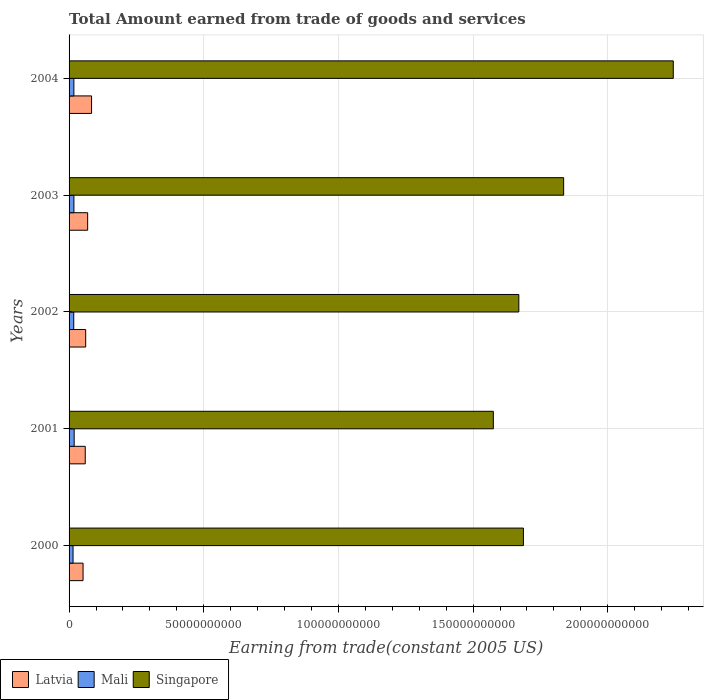Are the number of bars per tick equal to the number of legend labels?
Keep it short and to the point. Yes. Are the number of bars on each tick of the Y-axis equal?
Make the answer very short. Yes. What is the label of the 3rd group of bars from the top?
Your answer should be very brief. 2002. In how many cases, is the number of bars for a given year not equal to the number of legend labels?
Keep it short and to the point. 0. What is the total amount earned by trading goods and services in Mali in 2001?
Ensure brevity in your answer.  1.90e+09. Across all years, what is the maximum total amount earned by trading goods and services in Singapore?
Give a very brief answer. 2.24e+11. Across all years, what is the minimum total amount earned by trading goods and services in Singapore?
Keep it short and to the point. 1.58e+11. In which year was the total amount earned by trading goods and services in Latvia minimum?
Your answer should be very brief. 2000. What is the total total amount earned by trading goods and services in Latvia in the graph?
Provide a succinct answer. 3.26e+1. What is the difference between the total amount earned by trading goods and services in Latvia in 2003 and that in 2004?
Make the answer very short. -1.45e+09. What is the difference between the total amount earned by trading goods and services in Singapore in 2000 and the total amount earned by trading goods and services in Mali in 2003?
Offer a terse response. 1.67e+11. What is the average total amount earned by trading goods and services in Singapore per year?
Offer a terse response. 1.80e+11. In the year 2001, what is the difference between the total amount earned by trading goods and services in Latvia and total amount earned by trading goods and services in Singapore?
Provide a succinct answer. -1.52e+11. In how many years, is the total amount earned by trading goods and services in Mali greater than 220000000000 US$?
Offer a very short reply. 0. What is the ratio of the total amount earned by trading goods and services in Latvia in 2000 to that in 2004?
Your response must be concise. 0.62. What is the difference between the highest and the second highest total amount earned by trading goods and services in Mali?
Keep it short and to the point. 9.78e+07. What is the difference between the highest and the lowest total amount earned by trading goods and services in Latvia?
Provide a short and direct response. 3.16e+09. In how many years, is the total amount earned by trading goods and services in Latvia greater than the average total amount earned by trading goods and services in Latvia taken over all years?
Give a very brief answer. 2. What does the 1st bar from the top in 2004 represents?
Provide a short and direct response. Singapore. What does the 1st bar from the bottom in 2003 represents?
Keep it short and to the point. Latvia. Is it the case that in every year, the sum of the total amount earned by trading goods and services in Mali and total amount earned by trading goods and services in Latvia is greater than the total amount earned by trading goods and services in Singapore?
Make the answer very short. No. Are all the bars in the graph horizontal?
Your answer should be compact. Yes. What is the difference between two consecutive major ticks on the X-axis?
Offer a very short reply. 5.00e+1. Are the values on the major ticks of X-axis written in scientific E-notation?
Your response must be concise. No. Does the graph contain grids?
Your answer should be very brief. Yes. How many legend labels are there?
Offer a terse response. 3. How are the legend labels stacked?
Provide a succinct answer. Horizontal. What is the title of the graph?
Provide a succinct answer. Total Amount earned from trade of goods and services. What is the label or title of the X-axis?
Offer a very short reply. Earning from trade(constant 2005 US). What is the Earning from trade(constant 2005 US) in Latvia in 2000?
Offer a very short reply. 5.19e+09. What is the Earning from trade(constant 2005 US) of Mali in 2000?
Provide a succinct answer. 1.48e+09. What is the Earning from trade(constant 2005 US) of Singapore in 2000?
Provide a succinct answer. 1.69e+11. What is the Earning from trade(constant 2005 US) of Latvia in 2001?
Your answer should be very brief. 6.00e+09. What is the Earning from trade(constant 2005 US) in Mali in 2001?
Provide a succinct answer. 1.90e+09. What is the Earning from trade(constant 2005 US) in Singapore in 2001?
Keep it short and to the point. 1.58e+11. What is the Earning from trade(constant 2005 US) of Latvia in 2002?
Give a very brief answer. 6.17e+09. What is the Earning from trade(constant 2005 US) of Mali in 2002?
Your answer should be compact. 1.74e+09. What is the Earning from trade(constant 2005 US) in Singapore in 2002?
Make the answer very short. 1.67e+11. What is the Earning from trade(constant 2005 US) in Latvia in 2003?
Offer a terse response. 6.90e+09. What is the Earning from trade(constant 2005 US) of Mali in 2003?
Keep it short and to the point. 1.80e+09. What is the Earning from trade(constant 2005 US) of Singapore in 2003?
Ensure brevity in your answer.  1.84e+11. What is the Earning from trade(constant 2005 US) in Latvia in 2004?
Ensure brevity in your answer.  8.35e+09. What is the Earning from trade(constant 2005 US) in Mali in 2004?
Ensure brevity in your answer.  1.78e+09. What is the Earning from trade(constant 2005 US) in Singapore in 2004?
Give a very brief answer. 2.24e+11. Across all years, what is the maximum Earning from trade(constant 2005 US) in Latvia?
Make the answer very short. 8.35e+09. Across all years, what is the maximum Earning from trade(constant 2005 US) of Mali?
Ensure brevity in your answer.  1.90e+09. Across all years, what is the maximum Earning from trade(constant 2005 US) of Singapore?
Your response must be concise. 2.24e+11. Across all years, what is the minimum Earning from trade(constant 2005 US) of Latvia?
Your answer should be compact. 5.19e+09. Across all years, what is the minimum Earning from trade(constant 2005 US) in Mali?
Keep it short and to the point. 1.48e+09. Across all years, what is the minimum Earning from trade(constant 2005 US) of Singapore?
Ensure brevity in your answer.  1.58e+11. What is the total Earning from trade(constant 2005 US) of Latvia in the graph?
Offer a terse response. 3.26e+1. What is the total Earning from trade(constant 2005 US) in Mali in the graph?
Offer a very short reply. 8.69e+09. What is the total Earning from trade(constant 2005 US) of Singapore in the graph?
Provide a short and direct response. 9.01e+11. What is the difference between the Earning from trade(constant 2005 US) in Latvia in 2000 and that in 2001?
Your answer should be compact. -8.12e+08. What is the difference between the Earning from trade(constant 2005 US) of Mali in 2000 and that in 2001?
Offer a terse response. -4.19e+08. What is the difference between the Earning from trade(constant 2005 US) of Singapore in 2000 and that in 2001?
Provide a short and direct response. 1.12e+1. What is the difference between the Earning from trade(constant 2005 US) of Latvia in 2000 and that in 2002?
Ensure brevity in your answer.  -9.75e+08. What is the difference between the Earning from trade(constant 2005 US) of Mali in 2000 and that in 2002?
Keep it short and to the point. -2.61e+08. What is the difference between the Earning from trade(constant 2005 US) of Singapore in 2000 and that in 2002?
Give a very brief answer. 1.71e+09. What is the difference between the Earning from trade(constant 2005 US) in Latvia in 2000 and that in 2003?
Your answer should be compact. -1.71e+09. What is the difference between the Earning from trade(constant 2005 US) of Mali in 2000 and that in 2003?
Give a very brief answer. -3.21e+08. What is the difference between the Earning from trade(constant 2005 US) of Singapore in 2000 and that in 2003?
Your response must be concise. -1.49e+1. What is the difference between the Earning from trade(constant 2005 US) in Latvia in 2000 and that in 2004?
Your response must be concise. -3.16e+09. What is the difference between the Earning from trade(constant 2005 US) of Mali in 2000 and that in 2004?
Offer a terse response. -3.04e+08. What is the difference between the Earning from trade(constant 2005 US) in Singapore in 2000 and that in 2004?
Your response must be concise. -5.56e+1. What is the difference between the Earning from trade(constant 2005 US) of Latvia in 2001 and that in 2002?
Keep it short and to the point. -1.63e+08. What is the difference between the Earning from trade(constant 2005 US) of Mali in 2001 and that in 2002?
Ensure brevity in your answer.  1.57e+08. What is the difference between the Earning from trade(constant 2005 US) of Singapore in 2001 and that in 2002?
Make the answer very short. -9.46e+09. What is the difference between the Earning from trade(constant 2005 US) in Latvia in 2001 and that in 2003?
Give a very brief answer. -8.95e+08. What is the difference between the Earning from trade(constant 2005 US) of Mali in 2001 and that in 2003?
Make the answer very short. 9.78e+07. What is the difference between the Earning from trade(constant 2005 US) in Singapore in 2001 and that in 2003?
Give a very brief answer. -2.61e+1. What is the difference between the Earning from trade(constant 2005 US) of Latvia in 2001 and that in 2004?
Your response must be concise. -2.35e+09. What is the difference between the Earning from trade(constant 2005 US) in Mali in 2001 and that in 2004?
Ensure brevity in your answer.  1.15e+08. What is the difference between the Earning from trade(constant 2005 US) in Singapore in 2001 and that in 2004?
Offer a terse response. -6.68e+1. What is the difference between the Earning from trade(constant 2005 US) in Latvia in 2002 and that in 2003?
Ensure brevity in your answer.  -7.32e+08. What is the difference between the Earning from trade(constant 2005 US) in Mali in 2002 and that in 2003?
Provide a short and direct response. -5.94e+07. What is the difference between the Earning from trade(constant 2005 US) of Singapore in 2002 and that in 2003?
Offer a terse response. -1.66e+1. What is the difference between the Earning from trade(constant 2005 US) in Latvia in 2002 and that in 2004?
Provide a succinct answer. -2.18e+09. What is the difference between the Earning from trade(constant 2005 US) in Mali in 2002 and that in 2004?
Give a very brief answer. -4.25e+07. What is the difference between the Earning from trade(constant 2005 US) of Singapore in 2002 and that in 2004?
Provide a succinct answer. -5.73e+1. What is the difference between the Earning from trade(constant 2005 US) of Latvia in 2003 and that in 2004?
Provide a succinct answer. -1.45e+09. What is the difference between the Earning from trade(constant 2005 US) of Mali in 2003 and that in 2004?
Provide a succinct answer. 1.68e+07. What is the difference between the Earning from trade(constant 2005 US) of Singapore in 2003 and that in 2004?
Your answer should be compact. -4.07e+1. What is the difference between the Earning from trade(constant 2005 US) of Latvia in 2000 and the Earning from trade(constant 2005 US) of Mali in 2001?
Your answer should be very brief. 3.30e+09. What is the difference between the Earning from trade(constant 2005 US) of Latvia in 2000 and the Earning from trade(constant 2005 US) of Singapore in 2001?
Make the answer very short. -1.52e+11. What is the difference between the Earning from trade(constant 2005 US) in Mali in 2000 and the Earning from trade(constant 2005 US) in Singapore in 2001?
Your answer should be compact. -1.56e+11. What is the difference between the Earning from trade(constant 2005 US) of Latvia in 2000 and the Earning from trade(constant 2005 US) of Mali in 2002?
Offer a very short reply. 3.45e+09. What is the difference between the Earning from trade(constant 2005 US) of Latvia in 2000 and the Earning from trade(constant 2005 US) of Singapore in 2002?
Your answer should be very brief. -1.62e+11. What is the difference between the Earning from trade(constant 2005 US) in Mali in 2000 and the Earning from trade(constant 2005 US) in Singapore in 2002?
Make the answer very short. -1.65e+11. What is the difference between the Earning from trade(constant 2005 US) of Latvia in 2000 and the Earning from trade(constant 2005 US) of Mali in 2003?
Your answer should be compact. 3.39e+09. What is the difference between the Earning from trade(constant 2005 US) of Latvia in 2000 and the Earning from trade(constant 2005 US) of Singapore in 2003?
Offer a terse response. -1.78e+11. What is the difference between the Earning from trade(constant 2005 US) in Mali in 2000 and the Earning from trade(constant 2005 US) in Singapore in 2003?
Give a very brief answer. -1.82e+11. What is the difference between the Earning from trade(constant 2005 US) in Latvia in 2000 and the Earning from trade(constant 2005 US) in Mali in 2004?
Your response must be concise. 3.41e+09. What is the difference between the Earning from trade(constant 2005 US) of Latvia in 2000 and the Earning from trade(constant 2005 US) of Singapore in 2004?
Keep it short and to the point. -2.19e+11. What is the difference between the Earning from trade(constant 2005 US) in Mali in 2000 and the Earning from trade(constant 2005 US) in Singapore in 2004?
Offer a terse response. -2.23e+11. What is the difference between the Earning from trade(constant 2005 US) of Latvia in 2001 and the Earning from trade(constant 2005 US) of Mali in 2002?
Offer a very short reply. 4.27e+09. What is the difference between the Earning from trade(constant 2005 US) of Latvia in 2001 and the Earning from trade(constant 2005 US) of Singapore in 2002?
Provide a succinct answer. -1.61e+11. What is the difference between the Earning from trade(constant 2005 US) in Mali in 2001 and the Earning from trade(constant 2005 US) in Singapore in 2002?
Give a very brief answer. -1.65e+11. What is the difference between the Earning from trade(constant 2005 US) of Latvia in 2001 and the Earning from trade(constant 2005 US) of Mali in 2003?
Provide a short and direct response. 4.21e+09. What is the difference between the Earning from trade(constant 2005 US) in Latvia in 2001 and the Earning from trade(constant 2005 US) in Singapore in 2003?
Give a very brief answer. -1.78e+11. What is the difference between the Earning from trade(constant 2005 US) in Mali in 2001 and the Earning from trade(constant 2005 US) in Singapore in 2003?
Your answer should be compact. -1.82e+11. What is the difference between the Earning from trade(constant 2005 US) of Latvia in 2001 and the Earning from trade(constant 2005 US) of Mali in 2004?
Give a very brief answer. 4.22e+09. What is the difference between the Earning from trade(constant 2005 US) in Latvia in 2001 and the Earning from trade(constant 2005 US) in Singapore in 2004?
Give a very brief answer. -2.18e+11. What is the difference between the Earning from trade(constant 2005 US) in Mali in 2001 and the Earning from trade(constant 2005 US) in Singapore in 2004?
Offer a very short reply. -2.22e+11. What is the difference between the Earning from trade(constant 2005 US) in Latvia in 2002 and the Earning from trade(constant 2005 US) in Mali in 2003?
Keep it short and to the point. 4.37e+09. What is the difference between the Earning from trade(constant 2005 US) in Latvia in 2002 and the Earning from trade(constant 2005 US) in Singapore in 2003?
Ensure brevity in your answer.  -1.77e+11. What is the difference between the Earning from trade(constant 2005 US) of Mali in 2002 and the Earning from trade(constant 2005 US) of Singapore in 2003?
Your answer should be very brief. -1.82e+11. What is the difference between the Earning from trade(constant 2005 US) in Latvia in 2002 and the Earning from trade(constant 2005 US) in Mali in 2004?
Your response must be concise. 4.39e+09. What is the difference between the Earning from trade(constant 2005 US) in Latvia in 2002 and the Earning from trade(constant 2005 US) in Singapore in 2004?
Give a very brief answer. -2.18e+11. What is the difference between the Earning from trade(constant 2005 US) of Mali in 2002 and the Earning from trade(constant 2005 US) of Singapore in 2004?
Your response must be concise. -2.23e+11. What is the difference between the Earning from trade(constant 2005 US) in Latvia in 2003 and the Earning from trade(constant 2005 US) in Mali in 2004?
Your response must be concise. 5.12e+09. What is the difference between the Earning from trade(constant 2005 US) of Latvia in 2003 and the Earning from trade(constant 2005 US) of Singapore in 2004?
Give a very brief answer. -2.17e+11. What is the difference between the Earning from trade(constant 2005 US) in Mali in 2003 and the Earning from trade(constant 2005 US) in Singapore in 2004?
Provide a short and direct response. -2.23e+11. What is the average Earning from trade(constant 2005 US) in Latvia per year?
Keep it short and to the point. 6.52e+09. What is the average Earning from trade(constant 2005 US) in Mali per year?
Offer a very short reply. 1.74e+09. What is the average Earning from trade(constant 2005 US) in Singapore per year?
Provide a succinct answer. 1.80e+11. In the year 2000, what is the difference between the Earning from trade(constant 2005 US) in Latvia and Earning from trade(constant 2005 US) in Mali?
Keep it short and to the point. 3.71e+09. In the year 2000, what is the difference between the Earning from trade(constant 2005 US) of Latvia and Earning from trade(constant 2005 US) of Singapore?
Your answer should be very brief. -1.63e+11. In the year 2000, what is the difference between the Earning from trade(constant 2005 US) of Mali and Earning from trade(constant 2005 US) of Singapore?
Ensure brevity in your answer.  -1.67e+11. In the year 2001, what is the difference between the Earning from trade(constant 2005 US) of Latvia and Earning from trade(constant 2005 US) of Mali?
Provide a short and direct response. 4.11e+09. In the year 2001, what is the difference between the Earning from trade(constant 2005 US) in Latvia and Earning from trade(constant 2005 US) in Singapore?
Provide a short and direct response. -1.52e+11. In the year 2001, what is the difference between the Earning from trade(constant 2005 US) of Mali and Earning from trade(constant 2005 US) of Singapore?
Offer a very short reply. -1.56e+11. In the year 2002, what is the difference between the Earning from trade(constant 2005 US) of Latvia and Earning from trade(constant 2005 US) of Mali?
Provide a short and direct response. 4.43e+09. In the year 2002, what is the difference between the Earning from trade(constant 2005 US) in Latvia and Earning from trade(constant 2005 US) in Singapore?
Ensure brevity in your answer.  -1.61e+11. In the year 2002, what is the difference between the Earning from trade(constant 2005 US) of Mali and Earning from trade(constant 2005 US) of Singapore?
Your answer should be compact. -1.65e+11. In the year 2003, what is the difference between the Earning from trade(constant 2005 US) of Latvia and Earning from trade(constant 2005 US) of Mali?
Your answer should be compact. 5.10e+09. In the year 2003, what is the difference between the Earning from trade(constant 2005 US) of Latvia and Earning from trade(constant 2005 US) of Singapore?
Your answer should be compact. -1.77e+11. In the year 2003, what is the difference between the Earning from trade(constant 2005 US) in Mali and Earning from trade(constant 2005 US) in Singapore?
Keep it short and to the point. -1.82e+11. In the year 2004, what is the difference between the Earning from trade(constant 2005 US) in Latvia and Earning from trade(constant 2005 US) in Mali?
Offer a terse response. 6.57e+09. In the year 2004, what is the difference between the Earning from trade(constant 2005 US) of Latvia and Earning from trade(constant 2005 US) of Singapore?
Make the answer very short. -2.16e+11. In the year 2004, what is the difference between the Earning from trade(constant 2005 US) in Mali and Earning from trade(constant 2005 US) in Singapore?
Provide a short and direct response. -2.23e+11. What is the ratio of the Earning from trade(constant 2005 US) of Latvia in 2000 to that in 2001?
Ensure brevity in your answer.  0.86. What is the ratio of the Earning from trade(constant 2005 US) of Mali in 2000 to that in 2001?
Provide a succinct answer. 0.78. What is the ratio of the Earning from trade(constant 2005 US) of Singapore in 2000 to that in 2001?
Your response must be concise. 1.07. What is the ratio of the Earning from trade(constant 2005 US) in Latvia in 2000 to that in 2002?
Your answer should be very brief. 0.84. What is the ratio of the Earning from trade(constant 2005 US) of Mali in 2000 to that in 2002?
Your response must be concise. 0.85. What is the ratio of the Earning from trade(constant 2005 US) in Singapore in 2000 to that in 2002?
Ensure brevity in your answer.  1.01. What is the ratio of the Earning from trade(constant 2005 US) in Latvia in 2000 to that in 2003?
Offer a terse response. 0.75. What is the ratio of the Earning from trade(constant 2005 US) in Mali in 2000 to that in 2003?
Offer a very short reply. 0.82. What is the ratio of the Earning from trade(constant 2005 US) of Singapore in 2000 to that in 2003?
Provide a succinct answer. 0.92. What is the ratio of the Earning from trade(constant 2005 US) in Latvia in 2000 to that in 2004?
Make the answer very short. 0.62. What is the ratio of the Earning from trade(constant 2005 US) in Mali in 2000 to that in 2004?
Provide a succinct answer. 0.83. What is the ratio of the Earning from trade(constant 2005 US) of Singapore in 2000 to that in 2004?
Your response must be concise. 0.75. What is the ratio of the Earning from trade(constant 2005 US) in Latvia in 2001 to that in 2002?
Provide a succinct answer. 0.97. What is the ratio of the Earning from trade(constant 2005 US) in Mali in 2001 to that in 2002?
Offer a terse response. 1.09. What is the ratio of the Earning from trade(constant 2005 US) in Singapore in 2001 to that in 2002?
Provide a short and direct response. 0.94. What is the ratio of the Earning from trade(constant 2005 US) of Latvia in 2001 to that in 2003?
Offer a very short reply. 0.87. What is the ratio of the Earning from trade(constant 2005 US) in Mali in 2001 to that in 2003?
Ensure brevity in your answer.  1.05. What is the ratio of the Earning from trade(constant 2005 US) of Singapore in 2001 to that in 2003?
Give a very brief answer. 0.86. What is the ratio of the Earning from trade(constant 2005 US) in Latvia in 2001 to that in 2004?
Provide a succinct answer. 0.72. What is the ratio of the Earning from trade(constant 2005 US) in Mali in 2001 to that in 2004?
Offer a very short reply. 1.06. What is the ratio of the Earning from trade(constant 2005 US) of Singapore in 2001 to that in 2004?
Provide a short and direct response. 0.7. What is the ratio of the Earning from trade(constant 2005 US) in Latvia in 2002 to that in 2003?
Provide a short and direct response. 0.89. What is the ratio of the Earning from trade(constant 2005 US) in Singapore in 2002 to that in 2003?
Ensure brevity in your answer.  0.91. What is the ratio of the Earning from trade(constant 2005 US) of Latvia in 2002 to that in 2004?
Your answer should be compact. 0.74. What is the ratio of the Earning from trade(constant 2005 US) in Mali in 2002 to that in 2004?
Make the answer very short. 0.98. What is the ratio of the Earning from trade(constant 2005 US) of Singapore in 2002 to that in 2004?
Give a very brief answer. 0.74. What is the ratio of the Earning from trade(constant 2005 US) of Latvia in 2003 to that in 2004?
Your answer should be compact. 0.83. What is the ratio of the Earning from trade(constant 2005 US) in Mali in 2003 to that in 2004?
Your response must be concise. 1.01. What is the ratio of the Earning from trade(constant 2005 US) of Singapore in 2003 to that in 2004?
Make the answer very short. 0.82. What is the difference between the highest and the second highest Earning from trade(constant 2005 US) in Latvia?
Provide a succinct answer. 1.45e+09. What is the difference between the highest and the second highest Earning from trade(constant 2005 US) of Mali?
Provide a succinct answer. 9.78e+07. What is the difference between the highest and the second highest Earning from trade(constant 2005 US) in Singapore?
Provide a short and direct response. 4.07e+1. What is the difference between the highest and the lowest Earning from trade(constant 2005 US) of Latvia?
Make the answer very short. 3.16e+09. What is the difference between the highest and the lowest Earning from trade(constant 2005 US) in Mali?
Offer a terse response. 4.19e+08. What is the difference between the highest and the lowest Earning from trade(constant 2005 US) in Singapore?
Provide a succinct answer. 6.68e+1. 